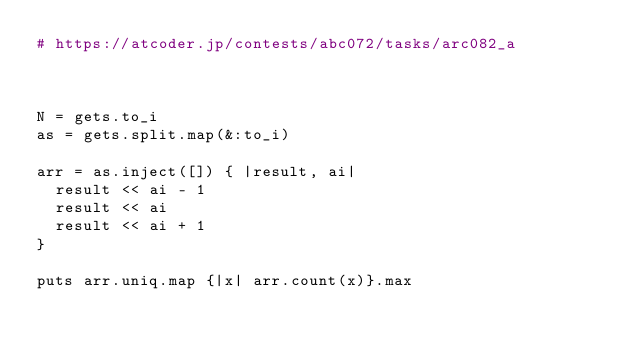<code> <loc_0><loc_0><loc_500><loc_500><_Ruby_># https://atcoder.jp/contests/abc072/tasks/arc082_a



N = gets.to_i
as = gets.split.map(&:to_i)

arr = as.inject([]) { |result, ai|
  result << ai - 1
  result << ai
  result << ai + 1
}

puts arr.uniq.map {|x| arr.count(x)}.max
</code> 